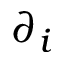Convert formula to latex. <formula><loc_0><loc_0><loc_500><loc_500>\partial _ { i }</formula> 